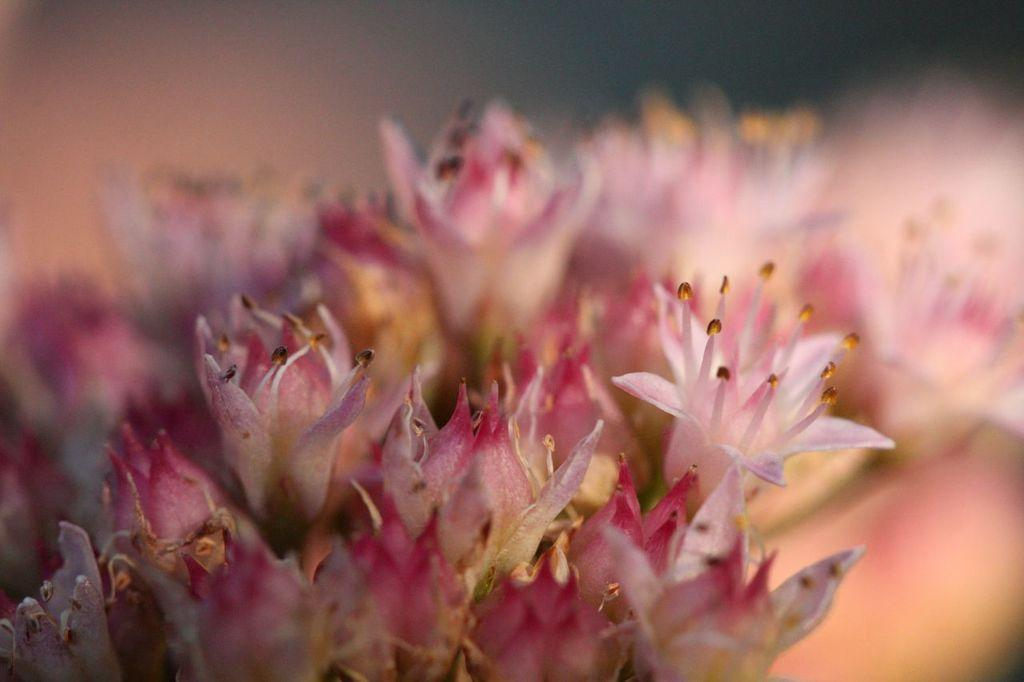What type of flowers can be seen in the image? There are pink flowers in the image. Is there a water-filled tub in the image? No, there is no water-filled tub present in the image. What type of control can be seen in the image? There is no control present in the image; it only features pink flowers. 